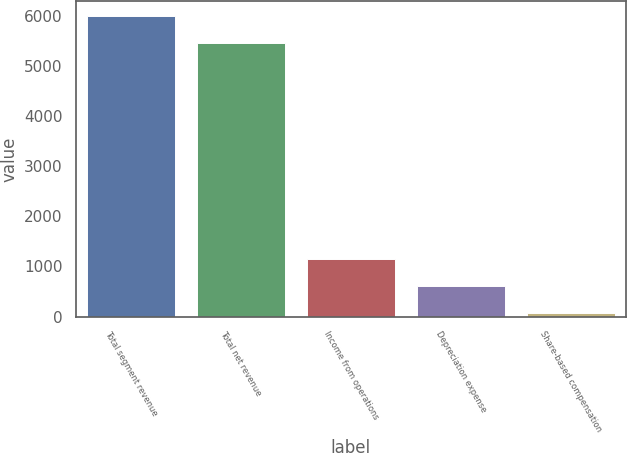<chart> <loc_0><loc_0><loc_500><loc_500><bar_chart><fcel>Total segment revenue<fcel>Total net revenue<fcel>Income from operations<fcel>Depreciation expense<fcel>Share-based compensation<nl><fcel>5983.9<fcel>5444<fcel>1143.8<fcel>603.9<fcel>64<nl></chart> 